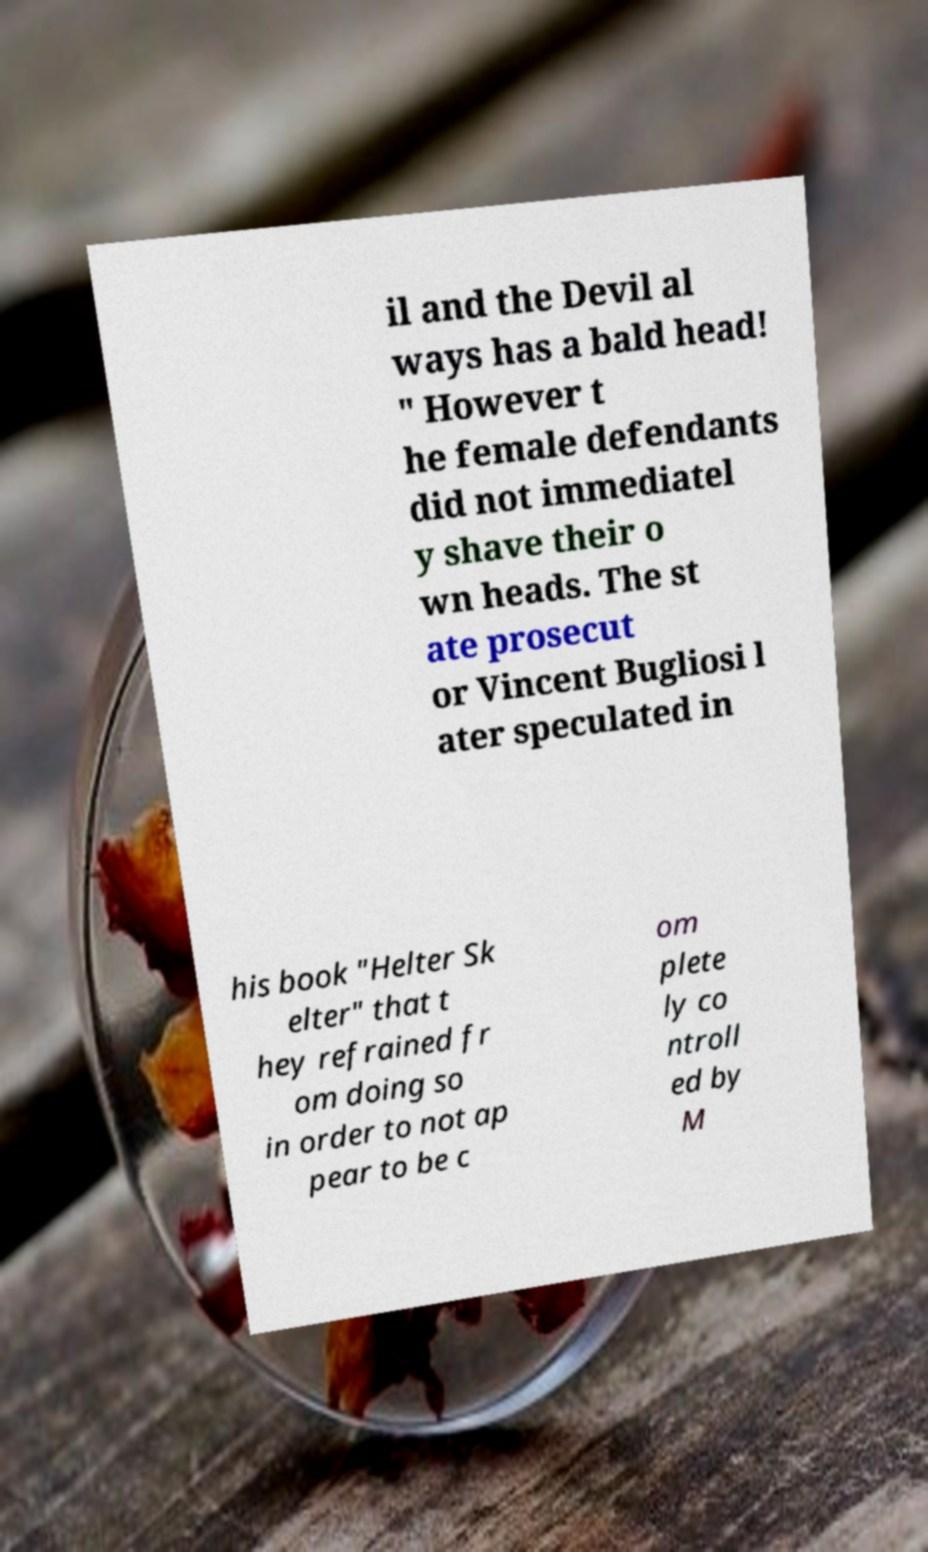Please identify and transcribe the text found in this image. il and the Devil al ways has a bald head! " However t he female defendants did not immediatel y shave their o wn heads. The st ate prosecut or Vincent Bugliosi l ater speculated in his book "Helter Sk elter" that t hey refrained fr om doing so in order to not ap pear to be c om plete ly co ntroll ed by M 